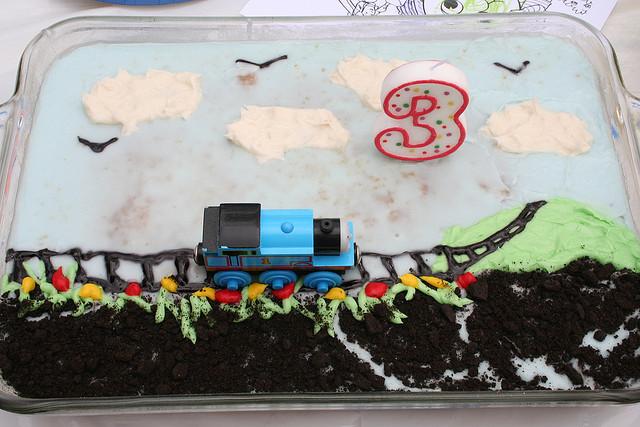What kind of food?
Short answer required. Cake. Is this cake for an adult?
Answer briefly. No. How old is Samuel turning this birthday?
Be succinct. 3. What is the theme of the party?
Give a very brief answer. Train. How old is Grant?
Quick response, please. 3. How many candles are on the cake?
Quick response, please. 1. What number is on the cake?
Give a very brief answer. 3. What kind of food is this?
Be succinct. Cake. What holiday is being celebrated?
Be succinct. Birthday. What does the cake say?
Be succinct. 3. What vegetable makes up the grass?
Short answer required. None. What's designed on the cake?
Quick response, please. Train. 